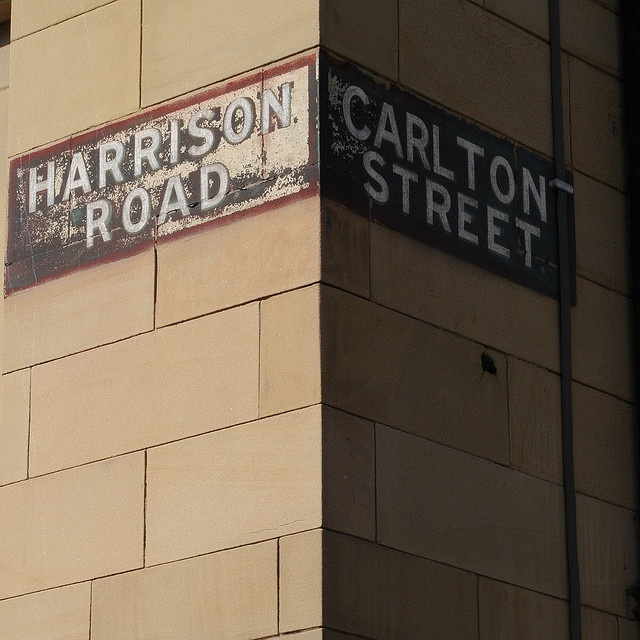Describe the objects in this image and their specific colors. I can see various objects in this image with different colors. 